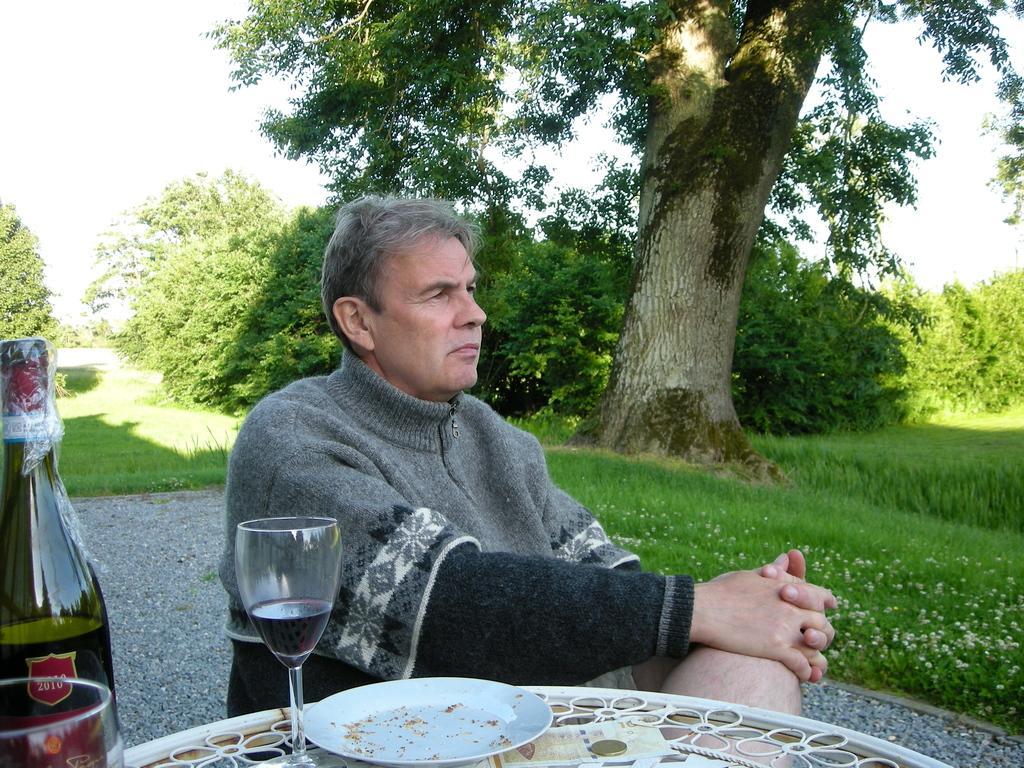How would you summarize this image in a sentence or two? This picture is taken in a garden. In the foreground of the picture there is a plate, glass and a bottle. In the center a man is seated. On the center there are trees. On the right and left there are trees. There is grass. In the picture sky is cloudy. 